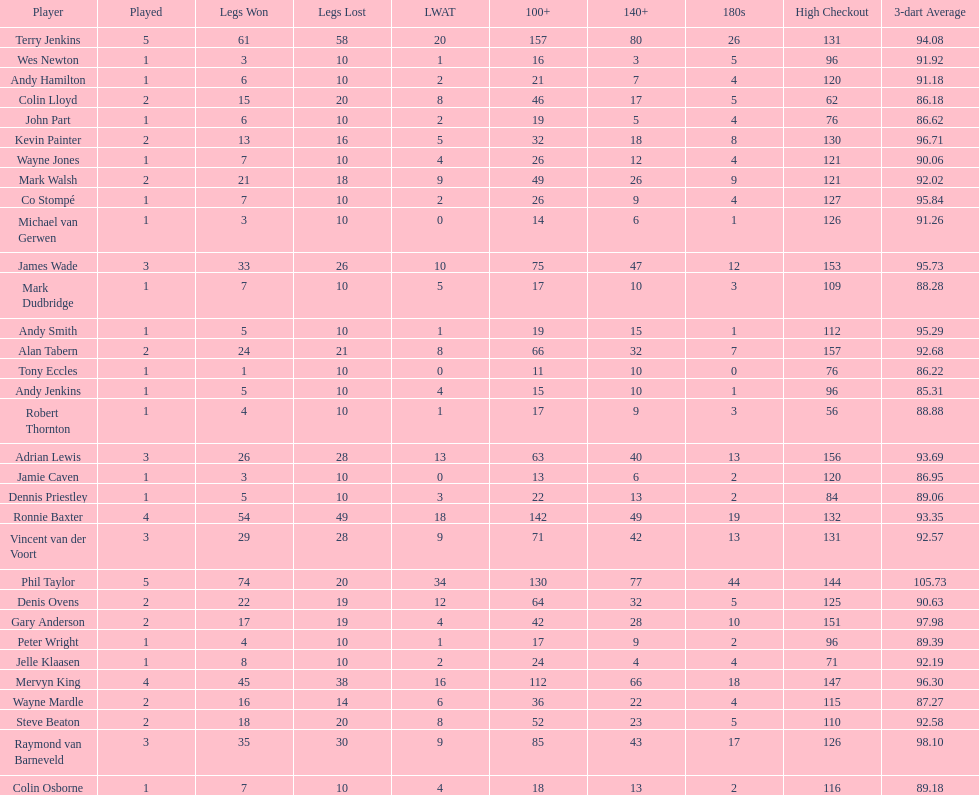List each of the players with a high checkout of 131. Terry Jenkins, Vincent van der Voort. 